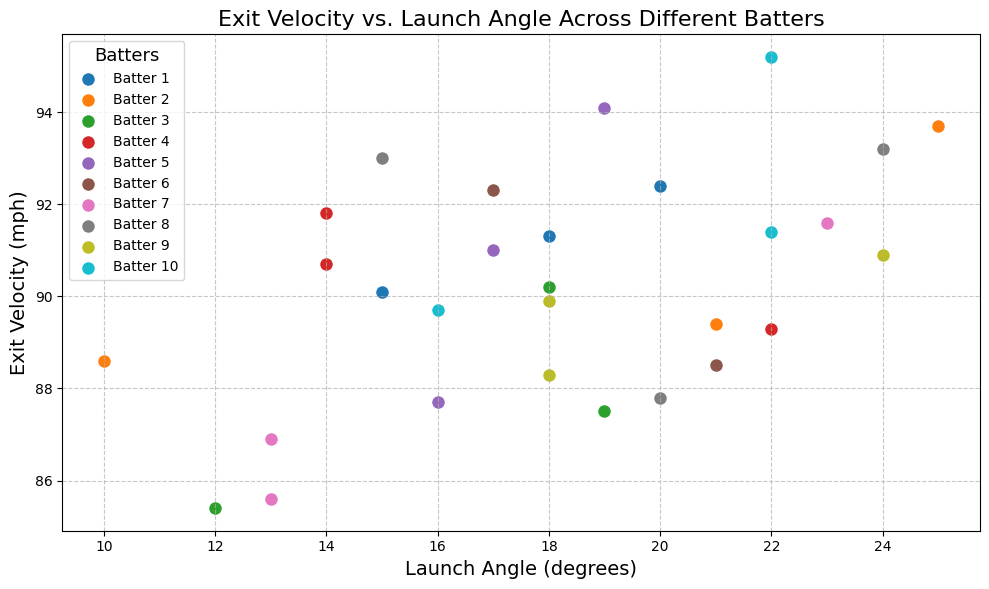Which batter has the highest average exit velocity? To find the batter with the highest average exit velocity, look at each batter's exit velocity values, sum them, and then find the average. Batter 10 has the values 89.7, 95.2, and 91.4. The total is 276.3 divided by 3, which equals 92.1, the highest among all batters.
Answer: Batter 10 Which batter has the highest maximum launch angle? To determine which batter has the highest maximum launch angle, review the highest value in the launch angle for each batter. Batter 9 hits an angle of 24 degrees, the highest among all batters.
Answer: Batter 9 Which batter has the most consistent exit velocity? Consistency can be assessed by looking at the range of exit velocities for each batter. Batter 8 has exit velocities 87.8, 93.0, and 93.2, where the range (max-min) is only 5.4, the smallest range among all batters, indicating high consistency.
Answer: Batter 8 Which batter’s data points form the tightest cluster on the scatter plot? To find the batter with the tightest cluster, visually inspect which batter’s data points are close to each other on the scatter plot. Batter 4's data points are close together around launch angles 14, 14, and 22, and exit velocities 89.3, 90.7, and 91.8.
Answer: Batter 4 Are there any batters with a negative correlation between exit velocity and launch angle? A negative correlation would indicate that as the launch angle increases, the exit velocity decreases. Visually inspect the scatter plot for any such pattern. None of the batters have a clear negative correlation visible on the plot.
Answer: No Which batter has the highest single exit velocity value? Scan through the exit velocities on the scatter plot. Batter 10 has the highest single exit velocity of 95.2 mph.
Answer: Batter 10 Do higher launch angles tend to coincide with higher exit velocities for any batter? To determine this, look for batters whose higher launch angles are paired with higher exit velocities on the plot. Batter 5, with launch angles around 16-19 degrees and exit velocities around 94.1, reflects this trend.
Answer: Batter 5 Is there a batter whose exit velocities are all above the mean exit velocity of the entire dataset? First, calculate the mean exit velocity of all batters: \( \text{Mean} = \frac{\text{Sum of all exit velocities}}{\text{Number of data points}}\). Then, check each batter's exit velocities. Batter 10 has all exit velocities (89.7, 95.2, 91.4) above the dataset mean (approximately 90.4 mph).
Answer: Batter 10 Which batter has the largest single discrepancy between two of their exit velocities? Examine the differences between individual exit velocities for each batter. Batter 10 has exit velocities of 89.7 and 95.2, giving a discrepancy of 5.5 mph, the largest among all batters.
Answer: Batter 10 